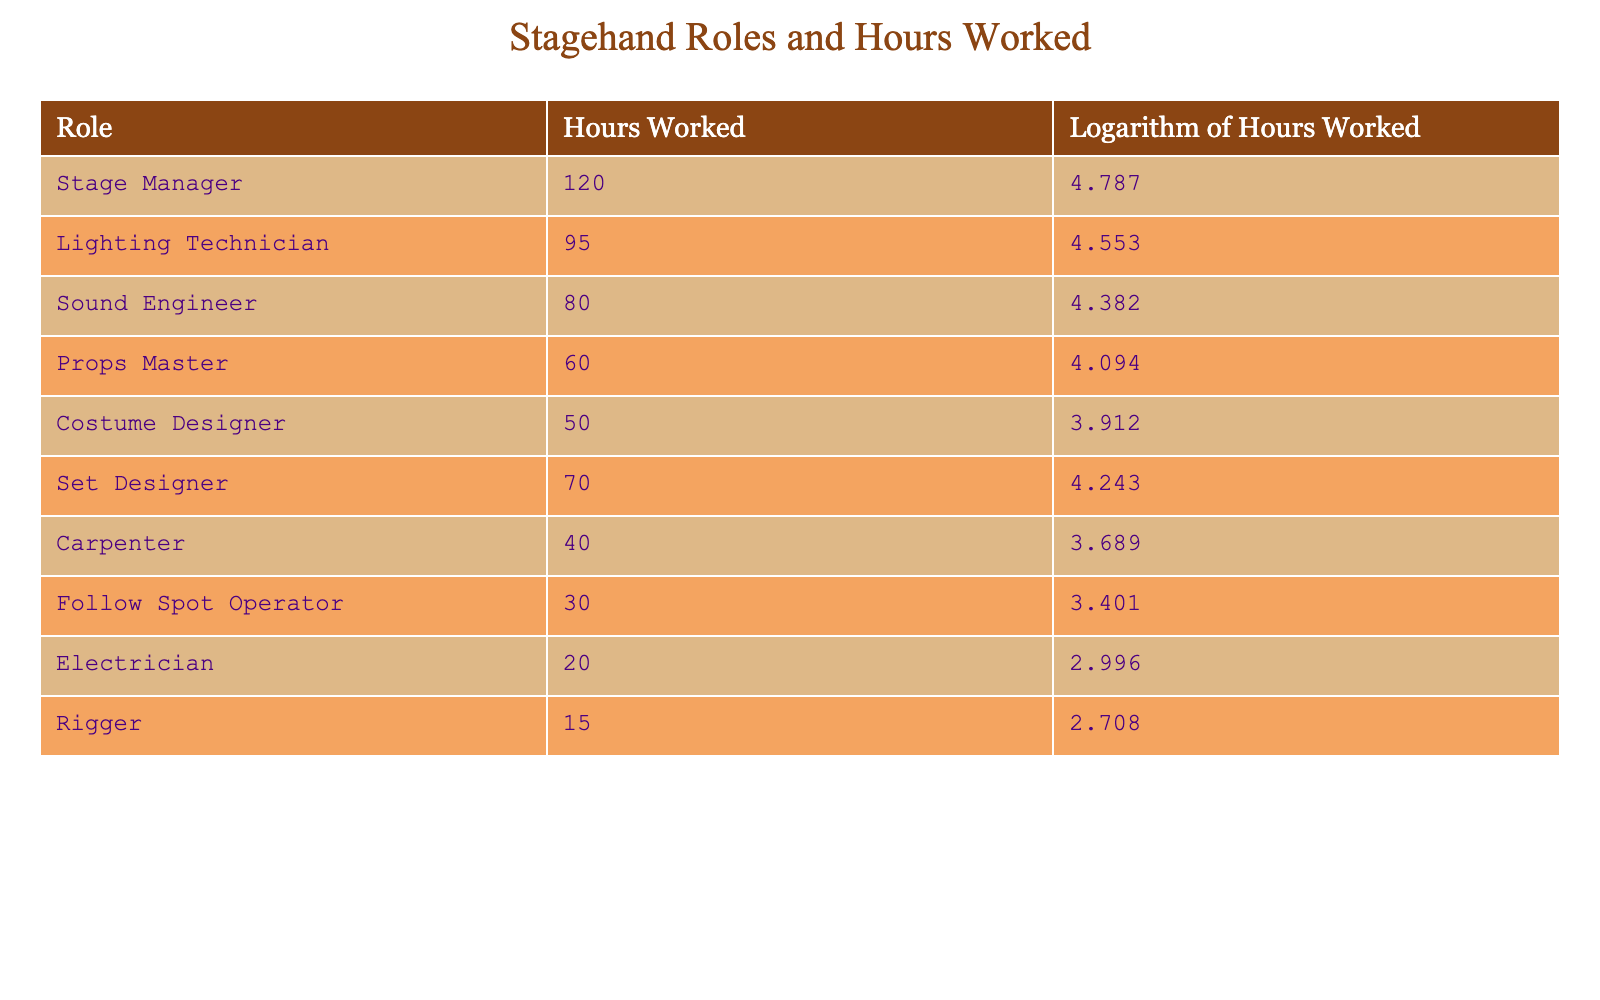What is the role with the highest hours worked? The role with the highest hours worked can be found by looking at the "Hours Worked" column. The value 120 hours corresponds to the role "Stage Manager."
Answer: Stage Manager How many hours did the Sound Engineer work? By scanning the "Hours Worked" column, we see that the "Sound Engineer" has a corresponding value of 80 hours.
Answer: 80 Is the Props Master role associated with more hours worked than the Rigger role? The Props Master worked 60 hours, and the Rigger worked 15 hours. Since 60 is greater than 15, the statement is true.
Answer: Yes What is the total number of hours worked by all roles combined? To find this, we add all the hours worked: 120 + 95 + 80 + 60 + 50 + 70 + 40 + 30 + 20 + 15 = 570. So the total combined hours is 570.
Answer: 570 What is the difference in hours between the Lighting Technician and the Electrician? The Lighting Technician worked 95 hours and the Electrician worked 20 hours. The difference is 95 - 20 = 75 hours.
Answer: 75 Which role has a logarithm of hours worked less than 4.0? Checking the "Logarithm of Hours Worked" column, we find "Carpenter," "Follow Spot Operator," and "Electrician" have logarithm values less than 4.0, which translates to their hours worked being less than 54.6.
Answer: Carpenter, Follow Spot Operator, Electrician What is the average number of hours worked across all roles? The total hours worked is 570 (calculated previously) divided by the number of roles, which is 10. Therefore, the average is 570/10 = 57 hours.
Answer: 57 Is the Logarithm of Hours Worked for the Costume Designer greater than the Set Designer? Consulting the "Logarithm of Hours Worked," we observe the Costume Designer has a value of 3.912 and the Set Designer has a value of 4.243. Since 3.912 is less than 4.243, the statement is false.
Answer: No What roles worked 70 hours or more? From the "Hours Worked" column, the roles with 70 hours or more are "Stage Manager" (120 hours), "Lighting Technician" (95 hours), "Sound Engineer" (80 hours), and "Set Designer" (70 hours).
Answer: Stage Manager, Lighting Technician, Sound Engineer, Set Designer 